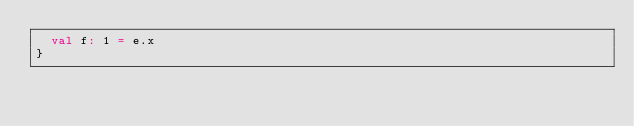Convert code to text. <code><loc_0><loc_0><loc_500><loc_500><_Scala_>  val f: 1 = e.x
}</code> 